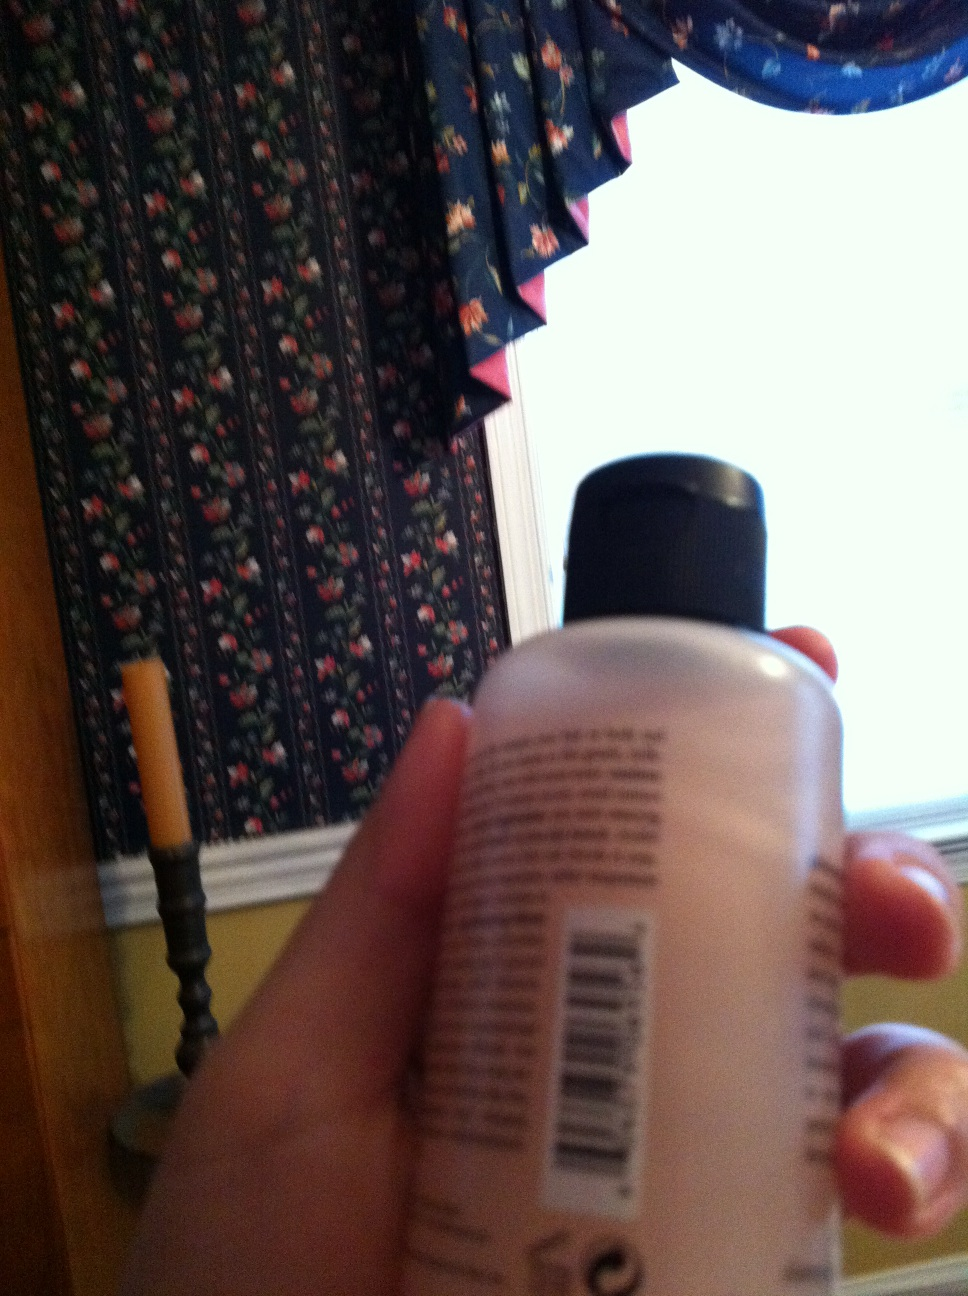What does this say? The image depicts a bottle held in someone's hand with text on it. However, the text is too blurry to read. Therefore, it is not possible to determine exactly what is written on the bottle. 